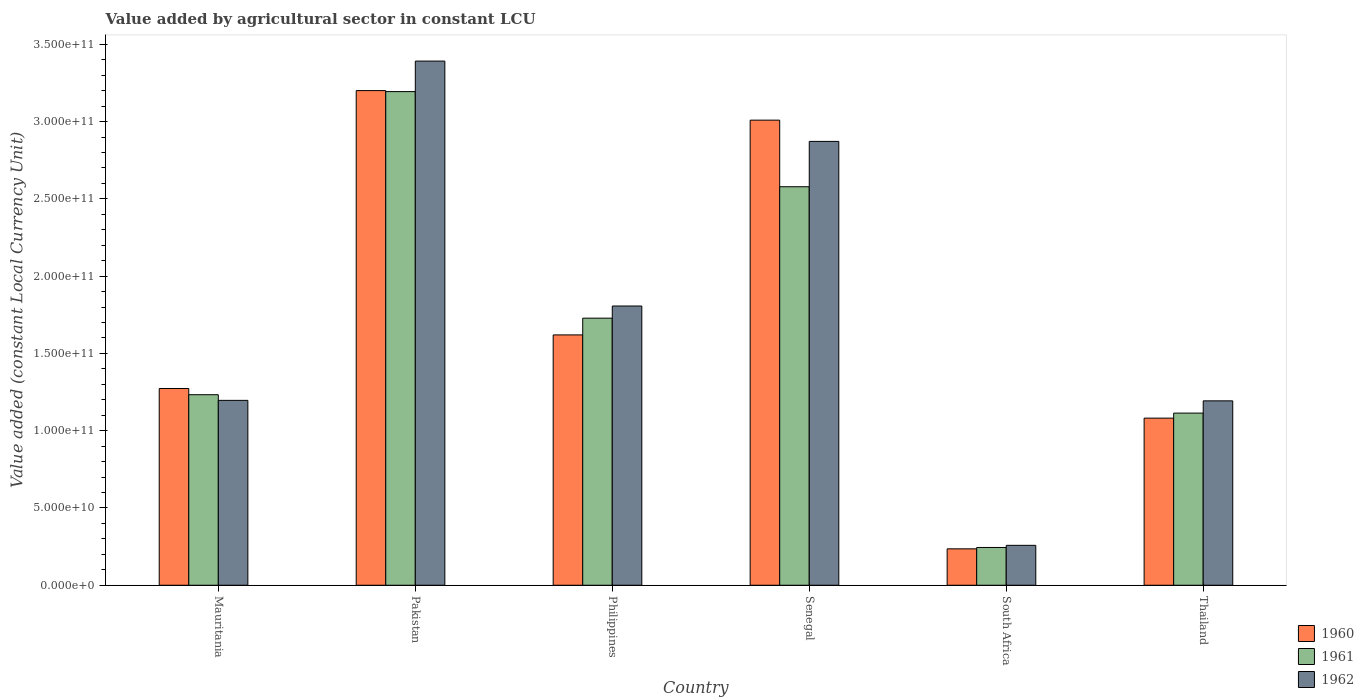Are the number of bars on each tick of the X-axis equal?
Provide a short and direct response. Yes. How many bars are there on the 6th tick from the left?
Offer a terse response. 3. What is the label of the 5th group of bars from the left?
Your answer should be very brief. South Africa. In how many cases, is the number of bars for a given country not equal to the number of legend labels?
Provide a succinct answer. 0. What is the value added by agricultural sector in 1960 in South Africa?
Your answer should be compact. 2.36e+1. Across all countries, what is the maximum value added by agricultural sector in 1960?
Offer a very short reply. 3.20e+11. Across all countries, what is the minimum value added by agricultural sector in 1960?
Ensure brevity in your answer.  2.36e+1. In which country was the value added by agricultural sector in 1962 maximum?
Provide a succinct answer. Pakistan. In which country was the value added by agricultural sector in 1960 minimum?
Your response must be concise. South Africa. What is the total value added by agricultural sector in 1962 in the graph?
Provide a succinct answer. 1.07e+12. What is the difference between the value added by agricultural sector in 1962 in South Africa and that in Thailand?
Keep it short and to the point. -9.35e+1. What is the difference between the value added by agricultural sector in 1960 in South Africa and the value added by agricultural sector in 1961 in Thailand?
Provide a short and direct response. -8.78e+1. What is the average value added by agricultural sector in 1961 per country?
Make the answer very short. 1.68e+11. What is the difference between the value added by agricultural sector of/in 1960 and value added by agricultural sector of/in 1961 in Mauritania?
Your answer should be very brief. 4.01e+09. In how many countries, is the value added by agricultural sector in 1961 greater than 50000000000 LCU?
Provide a succinct answer. 5. What is the ratio of the value added by agricultural sector in 1961 in Philippines to that in Senegal?
Provide a succinct answer. 0.67. What is the difference between the highest and the second highest value added by agricultural sector in 1960?
Ensure brevity in your answer.  1.91e+1. What is the difference between the highest and the lowest value added by agricultural sector in 1961?
Offer a terse response. 2.95e+11. Is it the case that in every country, the sum of the value added by agricultural sector in 1961 and value added by agricultural sector in 1962 is greater than the value added by agricultural sector in 1960?
Keep it short and to the point. Yes. How many bars are there?
Provide a short and direct response. 18. How many countries are there in the graph?
Ensure brevity in your answer.  6. Does the graph contain any zero values?
Your answer should be very brief. No. Does the graph contain grids?
Provide a succinct answer. No. How many legend labels are there?
Give a very brief answer. 3. What is the title of the graph?
Offer a very short reply. Value added by agricultural sector in constant LCU. What is the label or title of the X-axis?
Offer a terse response. Country. What is the label or title of the Y-axis?
Your response must be concise. Value added (constant Local Currency Unit). What is the Value added (constant Local Currency Unit) of 1960 in Mauritania?
Ensure brevity in your answer.  1.27e+11. What is the Value added (constant Local Currency Unit) in 1961 in Mauritania?
Make the answer very short. 1.23e+11. What is the Value added (constant Local Currency Unit) in 1962 in Mauritania?
Your answer should be very brief. 1.20e+11. What is the Value added (constant Local Currency Unit) of 1960 in Pakistan?
Give a very brief answer. 3.20e+11. What is the Value added (constant Local Currency Unit) in 1961 in Pakistan?
Your answer should be very brief. 3.19e+11. What is the Value added (constant Local Currency Unit) in 1962 in Pakistan?
Offer a very short reply. 3.39e+11. What is the Value added (constant Local Currency Unit) of 1960 in Philippines?
Your answer should be very brief. 1.62e+11. What is the Value added (constant Local Currency Unit) of 1961 in Philippines?
Your answer should be very brief. 1.73e+11. What is the Value added (constant Local Currency Unit) of 1962 in Philippines?
Ensure brevity in your answer.  1.81e+11. What is the Value added (constant Local Currency Unit) of 1960 in Senegal?
Your answer should be very brief. 3.01e+11. What is the Value added (constant Local Currency Unit) in 1961 in Senegal?
Provide a succinct answer. 2.58e+11. What is the Value added (constant Local Currency Unit) in 1962 in Senegal?
Offer a very short reply. 2.87e+11. What is the Value added (constant Local Currency Unit) in 1960 in South Africa?
Keep it short and to the point. 2.36e+1. What is the Value added (constant Local Currency Unit) of 1961 in South Africa?
Your answer should be very brief. 2.44e+1. What is the Value added (constant Local Currency Unit) of 1962 in South Africa?
Your answer should be compact. 2.58e+1. What is the Value added (constant Local Currency Unit) of 1960 in Thailand?
Offer a very short reply. 1.08e+11. What is the Value added (constant Local Currency Unit) of 1961 in Thailand?
Your response must be concise. 1.11e+11. What is the Value added (constant Local Currency Unit) in 1962 in Thailand?
Your response must be concise. 1.19e+11. Across all countries, what is the maximum Value added (constant Local Currency Unit) in 1960?
Give a very brief answer. 3.20e+11. Across all countries, what is the maximum Value added (constant Local Currency Unit) in 1961?
Your answer should be very brief. 3.19e+11. Across all countries, what is the maximum Value added (constant Local Currency Unit) in 1962?
Provide a succinct answer. 3.39e+11. Across all countries, what is the minimum Value added (constant Local Currency Unit) of 1960?
Your response must be concise. 2.36e+1. Across all countries, what is the minimum Value added (constant Local Currency Unit) in 1961?
Provide a short and direct response. 2.44e+1. Across all countries, what is the minimum Value added (constant Local Currency Unit) of 1962?
Keep it short and to the point. 2.58e+1. What is the total Value added (constant Local Currency Unit) of 1960 in the graph?
Your answer should be compact. 1.04e+12. What is the total Value added (constant Local Currency Unit) of 1961 in the graph?
Keep it short and to the point. 1.01e+12. What is the total Value added (constant Local Currency Unit) of 1962 in the graph?
Offer a very short reply. 1.07e+12. What is the difference between the Value added (constant Local Currency Unit) in 1960 in Mauritania and that in Pakistan?
Provide a short and direct response. -1.93e+11. What is the difference between the Value added (constant Local Currency Unit) in 1961 in Mauritania and that in Pakistan?
Provide a succinct answer. -1.96e+11. What is the difference between the Value added (constant Local Currency Unit) of 1962 in Mauritania and that in Pakistan?
Your answer should be very brief. -2.20e+11. What is the difference between the Value added (constant Local Currency Unit) in 1960 in Mauritania and that in Philippines?
Make the answer very short. -3.47e+1. What is the difference between the Value added (constant Local Currency Unit) of 1961 in Mauritania and that in Philippines?
Offer a very short reply. -4.95e+1. What is the difference between the Value added (constant Local Currency Unit) in 1962 in Mauritania and that in Philippines?
Ensure brevity in your answer.  -6.11e+1. What is the difference between the Value added (constant Local Currency Unit) in 1960 in Mauritania and that in Senegal?
Make the answer very short. -1.74e+11. What is the difference between the Value added (constant Local Currency Unit) of 1961 in Mauritania and that in Senegal?
Your answer should be very brief. -1.35e+11. What is the difference between the Value added (constant Local Currency Unit) of 1962 in Mauritania and that in Senegal?
Provide a succinct answer. -1.68e+11. What is the difference between the Value added (constant Local Currency Unit) in 1960 in Mauritania and that in South Africa?
Provide a short and direct response. 1.04e+11. What is the difference between the Value added (constant Local Currency Unit) of 1961 in Mauritania and that in South Africa?
Make the answer very short. 9.88e+1. What is the difference between the Value added (constant Local Currency Unit) in 1962 in Mauritania and that in South Africa?
Your answer should be very brief. 9.38e+1. What is the difference between the Value added (constant Local Currency Unit) of 1960 in Mauritania and that in Thailand?
Offer a terse response. 1.92e+1. What is the difference between the Value added (constant Local Currency Unit) of 1961 in Mauritania and that in Thailand?
Ensure brevity in your answer.  1.19e+1. What is the difference between the Value added (constant Local Currency Unit) of 1962 in Mauritania and that in Thailand?
Offer a terse response. 3.11e+08. What is the difference between the Value added (constant Local Currency Unit) in 1960 in Pakistan and that in Philippines?
Your answer should be very brief. 1.58e+11. What is the difference between the Value added (constant Local Currency Unit) of 1961 in Pakistan and that in Philippines?
Make the answer very short. 1.47e+11. What is the difference between the Value added (constant Local Currency Unit) in 1962 in Pakistan and that in Philippines?
Provide a succinct answer. 1.58e+11. What is the difference between the Value added (constant Local Currency Unit) of 1960 in Pakistan and that in Senegal?
Offer a very short reply. 1.91e+1. What is the difference between the Value added (constant Local Currency Unit) of 1961 in Pakistan and that in Senegal?
Offer a terse response. 6.16e+1. What is the difference between the Value added (constant Local Currency Unit) in 1962 in Pakistan and that in Senegal?
Provide a succinct answer. 5.20e+1. What is the difference between the Value added (constant Local Currency Unit) of 1960 in Pakistan and that in South Africa?
Give a very brief answer. 2.97e+11. What is the difference between the Value added (constant Local Currency Unit) of 1961 in Pakistan and that in South Africa?
Your response must be concise. 2.95e+11. What is the difference between the Value added (constant Local Currency Unit) of 1962 in Pakistan and that in South Africa?
Offer a terse response. 3.13e+11. What is the difference between the Value added (constant Local Currency Unit) of 1960 in Pakistan and that in Thailand?
Your answer should be very brief. 2.12e+11. What is the difference between the Value added (constant Local Currency Unit) in 1961 in Pakistan and that in Thailand?
Offer a very short reply. 2.08e+11. What is the difference between the Value added (constant Local Currency Unit) in 1962 in Pakistan and that in Thailand?
Your answer should be compact. 2.20e+11. What is the difference between the Value added (constant Local Currency Unit) in 1960 in Philippines and that in Senegal?
Provide a succinct answer. -1.39e+11. What is the difference between the Value added (constant Local Currency Unit) in 1961 in Philippines and that in Senegal?
Keep it short and to the point. -8.50e+1. What is the difference between the Value added (constant Local Currency Unit) in 1962 in Philippines and that in Senegal?
Offer a very short reply. -1.07e+11. What is the difference between the Value added (constant Local Currency Unit) in 1960 in Philippines and that in South Africa?
Your answer should be very brief. 1.38e+11. What is the difference between the Value added (constant Local Currency Unit) of 1961 in Philippines and that in South Africa?
Keep it short and to the point. 1.48e+11. What is the difference between the Value added (constant Local Currency Unit) in 1962 in Philippines and that in South Africa?
Provide a short and direct response. 1.55e+11. What is the difference between the Value added (constant Local Currency Unit) of 1960 in Philippines and that in Thailand?
Your response must be concise. 5.39e+1. What is the difference between the Value added (constant Local Currency Unit) of 1961 in Philippines and that in Thailand?
Make the answer very short. 6.14e+1. What is the difference between the Value added (constant Local Currency Unit) in 1962 in Philippines and that in Thailand?
Make the answer very short. 6.14e+1. What is the difference between the Value added (constant Local Currency Unit) in 1960 in Senegal and that in South Africa?
Ensure brevity in your answer.  2.77e+11. What is the difference between the Value added (constant Local Currency Unit) in 1961 in Senegal and that in South Africa?
Offer a very short reply. 2.33e+11. What is the difference between the Value added (constant Local Currency Unit) in 1962 in Senegal and that in South Africa?
Give a very brief answer. 2.61e+11. What is the difference between the Value added (constant Local Currency Unit) of 1960 in Senegal and that in Thailand?
Your answer should be very brief. 1.93e+11. What is the difference between the Value added (constant Local Currency Unit) of 1961 in Senegal and that in Thailand?
Provide a succinct answer. 1.46e+11. What is the difference between the Value added (constant Local Currency Unit) in 1962 in Senegal and that in Thailand?
Offer a terse response. 1.68e+11. What is the difference between the Value added (constant Local Currency Unit) in 1960 in South Africa and that in Thailand?
Offer a terse response. -8.46e+1. What is the difference between the Value added (constant Local Currency Unit) in 1961 in South Africa and that in Thailand?
Your response must be concise. -8.70e+1. What is the difference between the Value added (constant Local Currency Unit) of 1962 in South Africa and that in Thailand?
Give a very brief answer. -9.35e+1. What is the difference between the Value added (constant Local Currency Unit) in 1960 in Mauritania and the Value added (constant Local Currency Unit) in 1961 in Pakistan?
Offer a terse response. -1.92e+11. What is the difference between the Value added (constant Local Currency Unit) of 1960 in Mauritania and the Value added (constant Local Currency Unit) of 1962 in Pakistan?
Provide a short and direct response. -2.12e+11. What is the difference between the Value added (constant Local Currency Unit) in 1961 in Mauritania and the Value added (constant Local Currency Unit) in 1962 in Pakistan?
Offer a terse response. -2.16e+11. What is the difference between the Value added (constant Local Currency Unit) of 1960 in Mauritania and the Value added (constant Local Currency Unit) of 1961 in Philippines?
Make the answer very short. -4.55e+1. What is the difference between the Value added (constant Local Currency Unit) of 1960 in Mauritania and the Value added (constant Local Currency Unit) of 1962 in Philippines?
Make the answer very short. -5.34e+1. What is the difference between the Value added (constant Local Currency Unit) of 1961 in Mauritania and the Value added (constant Local Currency Unit) of 1962 in Philippines?
Offer a terse response. -5.74e+1. What is the difference between the Value added (constant Local Currency Unit) in 1960 in Mauritania and the Value added (constant Local Currency Unit) in 1961 in Senegal?
Provide a succinct answer. -1.31e+11. What is the difference between the Value added (constant Local Currency Unit) in 1960 in Mauritania and the Value added (constant Local Currency Unit) in 1962 in Senegal?
Provide a succinct answer. -1.60e+11. What is the difference between the Value added (constant Local Currency Unit) of 1961 in Mauritania and the Value added (constant Local Currency Unit) of 1962 in Senegal?
Offer a terse response. -1.64e+11. What is the difference between the Value added (constant Local Currency Unit) in 1960 in Mauritania and the Value added (constant Local Currency Unit) in 1961 in South Africa?
Provide a succinct answer. 1.03e+11. What is the difference between the Value added (constant Local Currency Unit) of 1960 in Mauritania and the Value added (constant Local Currency Unit) of 1962 in South Africa?
Ensure brevity in your answer.  1.01e+11. What is the difference between the Value added (constant Local Currency Unit) in 1961 in Mauritania and the Value added (constant Local Currency Unit) in 1962 in South Africa?
Your answer should be compact. 9.75e+1. What is the difference between the Value added (constant Local Currency Unit) of 1960 in Mauritania and the Value added (constant Local Currency Unit) of 1961 in Thailand?
Offer a terse response. 1.59e+1. What is the difference between the Value added (constant Local Currency Unit) in 1960 in Mauritania and the Value added (constant Local Currency Unit) in 1962 in Thailand?
Ensure brevity in your answer.  7.98e+09. What is the difference between the Value added (constant Local Currency Unit) of 1961 in Mauritania and the Value added (constant Local Currency Unit) of 1962 in Thailand?
Offer a terse response. 3.97e+09. What is the difference between the Value added (constant Local Currency Unit) in 1960 in Pakistan and the Value added (constant Local Currency Unit) in 1961 in Philippines?
Provide a succinct answer. 1.47e+11. What is the difference between the Value added (constant Local Currency Unit) in 1960 in Pakistan and the Value added (constant Local Currency Unit) in 1962 in Philippines?
Make the answer very short. 1.39e+11. What is the difference between the Value added (constant Local Currency Unit) of 1961 in Pakistan and the Value added (constant Local Currency Unit) of 1962 in Philippines?
Make the answer very short. 1.39e+11. What is the difference between the Value added (constant Local Currency Unit) in 1960 in Pakistan and the Value added (constant Local Currency Unit) in 1961 in Senegal?
Your answer should be compact. 6.22e+1. What is the difference between the Value added (constant Local Currency Unit) in 1960 in Pakistan and the Value added (constant Local Currency Unit) in 1962 in Senegal?
Your answer should be very brief. 3.29e+1. What is the difference between the Value added (constant Local Currency Unit) of 1961 in Pakistan and the Value added (constant Local Currency Unit) of 1962 in Senegal?
Give a very brief answer. 3.22e+1. What is the difference between the Value added (constant Local Currency Unit) in 1960 in Pakistan and the Value added (constant Local Currency Unit) in 1961 in South Africa?
Provide a short and direct response. 2.96e+11. What is the difference between the Value added (constant Local Currency Unit) of 1960 in Pakistan and the Value added (constant Local Currency Unit) of 1962 in South Africa?
Ensure brevity in your answer.  2.94e+11. What is the difference between the Value added (constant Local Currency Unit) of 1961 in Pakistan and the Value added (constant Local Currency Unit) of 1962 in South Africa?
Keep it short and to the point. 2.94e+11. What is the difference between the Value added (constant Local Currency Unit) of 1960 in Pakistan and the Value added (constant Local Currency Unit) of 1961 in Thailand?
Your answer should be very brief. 2.09e+11. What is the difference between the Value added (constant Local Currency Unit) of 1960 in Pakistan and the Value added (constant Local Currency Unit) of 1962 in Thailand?
Your response must be concise. 2.01e+11. What is the difference between the Value added (constant Local Currency Unit) of 1961 in Pakistan and the Value added (constant Local Currency Unit) of 1962 in Thailand?
Provide a succinct answer. 2.00e+11. What is the difference between the Value added (constant Local Currency Unit) of 1960 in Philippines and the Value added (constant Local Currency Unit) of 1961 in Senegal?
Give a very brief answer. -9.59e+1. What is the difference between the Value added (constant Local Currency Unit) in 1960 in Philippines and the Value added (constant Local Currency Unit) in 1962 in Senegal?
Provide a short and direct response. -1.25e+11. What is the difference between the Value added (constant Local Currency Unit) in 1961 in Philippines and the Value added (constant Local Currency Unit) in 1962 in Senegal?
Your answer should be very brief. -1.14e+11. What is the difference between the Value added (constant Local Currency Unit) in 1960 in Philippines and the Value added (constant Local Currency Unit) in 1961 in South Africa?
Provide a short and direct response. 1.38e+11. What is the difference between the Value added (constant Local Currency Unit) of 1960 in Philippines and the Value added (constant Local Currency Unit) of 1962 in South Africa?
Give a very brief answer. 1.36e+11. What is the difference between the Value added (constant Local Currency Unit) in 1961 in Philippines and the Value added (constant Local Currency Unit) in 1962 in South Africa?
Offer a very short reply. 1.47e+11. What is the difference between the Value added (constant Local Currency Unit) in 1960 in Philippines and the Value added (constant Local Currency Unit) in 1961 in Thailand?
Offer a terse response. 5.06e+1. What is the difference between the Value added (constant Local Currency Unit) in 1960 in Philippines and the Value added (constant Local Currency Unit) in 1962 in Thailand?
Give a very brief answer. 4.27e+1. What is the difference between the Value added (constant Local Currency Unit) of 1961 in Philippines and the Value added (constant Local Currency Unit) of 1962 in Thailand?
Offer a very short reply. 5.35e+1. What is the difference between the Value added (constant Local Currency Unit) in 1960 in Senegal and the Value added (constant Local Currency Unit) in 1961 in South Africa?
Your answer should be very brief. 2.77e+11. What is the difference between the Value added (constant Local Currency Unit) in 1960 in Senegal and the Value added (constant Local Currency Unit) in 1962 in South Africa?
Ensure brevity in your answer.  2.75e+11. What is the difference between the Value added (constant Local Currency Unit) of 1961 in Senegal and the Value added (constant Local Currency Unit) of 1962 in South Africa?
Offer a very short reply. 2.32e+11. What is the difference between the Value added (constant Local Currency Unit) of 1960 in Senegal and the Value added (constant Local Currency Unit) of 1961 in Thailand?
Offer a very short reply. 1.90e+11. What is the difference between the Value added (constant Local Currency Unit) in 1960 in Senegal and the Value added (constant Local Currency Unit) in 1962 in Thailand?
Your answer should be compact. 1.82e+11. What is the difference between the Value added (constant Local Currency Unit) in 1961 in Senegal and the Value added (constant Local Currency Unit) in 1962 in Thailand?
Your answer should be compact. 1.39e+11. What is the difference between the Value added (constant Local Currency Unit) of 1960 in South Africa and the Value added (constant Local Currency Unit) of 1961 in Thailand?
Offer a very short reply. -8.78e+1. What is the difference between the Value added (constant Local Currency Unit) of 1960 in South Africa and the Value added (constant Local Currency Unit) of 1962 in Thailand?
Offer a very short reply. -9.58e+1. What is the difference between the Value added (constant Local Currency Unit) of 1961 in South Africa and the Value added (constant Local Currency Unit) of 1962 in Thailand?
Make the answer very short. -9.49e+1. What is the average Value added (constant Local Currency Unit) in 1960 per country?
Make the answer very short. 1.74e+11. What is the average Value added (constant Local Currency Unit) of 1961 per country?
Give a very brief answer. 1.68e+11. What is the average Value added (constant Local Currency Unit) in 1962 per country?
Make the answer very short. 1.79e+11. What is the difference between the Value added (constant Local Currency Unit) of 1960 and Value added (constant Local Currency Unit) of 1961 in Mauritania?
Your answer should be compact. 4.01e+09. What is the difference between the Value added (constant Local Currency Unit) of 1960 and Value added (constant Local Currency Unit) of 1962 in Mauritania?
Give a very brief answer. 7.67e+09. What is the difference between the Value added (constant Local Currency Unit) of 1961 and Value added (constant Local Currency Unit) of 1962 in Mauritania?
Provide a succinct answer. 3.65e+09. What is the difference between the Value added (constant Local Currency Unit) in 1960 and Value added (constant Local Currency Unit) in 1961 in Pakistan?
Offer a terse response. 6.46e+08. What is the difference between the Value added (constant Local Currency Unit) in 1960 and Value added (constant Local Currency Unit) in 1962 in Pakistan?
Provide a short and direct response. -1.91e+1. What is the difference between the Value added (constant Local Currency Unit) of 1961 and Value added (constant Local Currency Unit) of 1962 in Pakistan?
Your response must be concise. -1.97e+1. What is the difference between the Value added (constant Local Currency Unit) in 1960 and Value added (constant Local Currency Unit) in 1961 in Philippines?
Ensure brevity in your answer.  -1.08e+1. What is the difference between the Value added (constant Local Currency Unit) in 1960 and Value added (constant Local Currency Unit) in 1962 in Philippines?
Ensure brevity in your answer.  -1.87e+1. What is the difference between the Value added (constant Local Currency Unit) of 1961 and Value added (constant Local Currency Unit) of 1962 in Philippines?
Ensure brevity in your answer.  -7.86e+09. What is the difference between the Value added (constant Local Currency Unit) of 1960 and Value added (constant Local Currency Unit) of 1961 in Senegal?
Your answer should be very brief. 4.31e+1. What is the difference between the Value added (constant Local Currency Unit) of 1960 and Value added (constant Local Currency Unit) of 1962 in Senegal?
Make the answer very short. 1.38e+1. What is the difference between the Value added (constant Local Currency Unit) of 1961 and Value added (constant Local Currency Unit) of 1962 in Senegal?
Your response must be concise. -2.93e+1. What is the difference between the Value added (constant Local Currency Unit) of 1960 and Value added (constant Local Currency Unit) of 1961 in South Africa?
Give a very brief answer. -8.75e+08. What is the difference between the Value added (constant Local Currency Unit) in 1960 and Value added (constant Local Currency Unit) in 1962 in South Africa?
Keep it short and to the point. -2.26e+09. What is the difference between the Value added (constant Local Currency Unit) of 1961 and Value added (constant Local Currency Unit) of 1962 in South Africa?
Provide a succinct answer. -1.39e+09. What is the difference between the Value added (constant Local Currency Unit) in 1960 and Value added (constant Local Currency Unit) in 1961 in Thailand?
Your answer should be very brief. -3.26e+09. What is the difference between the Value added (constant Local Currency Unit) of 1960 and Value added (constant Local Currency Unit) of 1962 in Thailand?
Give a very brief answer. -1.12e+1. What is the difference between the Value added (constant Local Currency Unit) of 1961 and Value added (constant Local Currency Unit) of 1962 in Thailand?
Give a very brief answer. -7.93e+09. What is the ratio of the Value added (constant Local Currency Unit) of 1960 in Mauritania to that in Pakistan?
Make the answer very short. 0.4. What is the ratio of the Value added (constant Local Currency Unit) in 1961 in Mauritania to that in Pakistan?
Provide a short and direct response. 0.39. What is the ratio of the Value added (constant Local Currency Unit) in 1962 in Mauritania to that in Pakistan?
Give a very brief answer. 0.35. What is the ratio of the Value added (constant Local Currency Unit) of 1960 in Mauritania to that in Philippines?
Ensure brevity in your answer.  0.79. What is the ratio of the Value added (constant Local Currency Unit) in 1961 in Mauritania to that in Philippines?
Offer a terse response. 0.71. What is the ratio of the Value added (constant Local Currency Unit) of 1962 in Mauritania to that in Philippines?
Keep it short and to the point. 0.66. What is the ratio of the Value added (constant Local Currency Unit) in 1960 in Mauritania to that in Senegal?
Keep it short and to the point. 0.42. What is the ratio of the Value added (constant Local Currency Unit) of 1961 in Mauritania to that in Senegal?
Your answer should be compact. 0.48. What is the ratio of the Value added (constant Local Currency Unit) in 1962 in Mauritania to that in Senegal?
Ensure brevity in your answer.  0.42. What is the ratio of the Value added (constant Local Currency Unit) in 1960 in Mauritania to that in South Africa?
Ensure brevity in your answer.  5.4. What is the ratio of the Value added (constant Local Currency Unit) in 1961 in Mauritania to that in South Africa?
Provide a succinct answer. 5.05. What is the ratio of the Value added (constant Local Currency Unit) of 1962 in Mauritania to that in South Africa?
Your response must be concise. 4.63. What is the ratio of the Value added (constant Local Currency Unit) in 1960 in Mauritania to that in Thailand?
Your response must be concise. 1.18. What is the ratio of the Value added (constant Local Currency Unit) of 1961 in Mauritania to that in Thailand?
Your response must be concise. 1.11. What is the ratio of the Value added (constant Local Currency Unit) in 1962 in Mauritania to that in Thailand?
Ensure brevity in your answer.  1. What is the ratio of the Value added (constant Local Currency Unit) of 1960 in Pakistan to that in Philippines?
Your answer should be compact. 1.98. What is the ratio of the Value added (constant Local Currency Unit) of 1961 in Pakistan to that in Philippines?
Your answer should be very brief. 1.85. What is the ratio of the Value added (constant Local Currency Unit) of 1962 in Pakistan to that in Philippines?
Your answer should be compact. 1.88. What is the ratio of the Value added (constant Local Currency Unit) of 1960 in Pakistan to that in Senegal?
Your answer should be very brief. 1.06. What is the ratio of the Value added (constant Local Currency Unit) of 1961 in Pakistan to that in Senegal?
Keep it short and to the point. 1.24. What is the ratio of the Value added (constant Local Currency Unit) in 1962 in Pakistan to that in Senegal?
Give a very brief answer. 1.18. What is the ratio of the Value added (constant Local Currency Unit) in 1960 in Pakistan to that in South Africa?
Offer a very short reply. 13.59. What is the ratio of the Value added (constant Local Currency Unit) in 1961 in Pakistan to that in South Africa?
Your response must be concise. 13.07. What is the ratio of the Value added (constant Local Currency Unit) in 1962 in Pakistan to that in South Africa?
Ensure brevity in your answer.  13.14. What is the ratio of the Value added (constant Local Currency Unit) of 1960 in Pakistan to that in Thailand?
Your answer should be very brief. 2.96. What is the ratio of the Value added (constant Local Currency Unit) in 1961 in Pakistan to that in Thailand?
Provide a succinct answer. 2.87. What is the ratio of the Value added (constant Local Currency Unit) of 1962 in Pakistan to that in Thailand?
Your response must be concise. 2.84. What is the ratio of the Value added (constant Local Currency Unit) in 1960 in Philippines to that in Senegal?
Your response must be concise. 0.54. What is the ratio of the Value added (constant Local Currency Unit) of 1961 in Philippines to that in Senegal?
Your answer should be very brief. 0.67. What is the ratio of the Value added (constant Local Currency Unit) of 1962 in Philippines to that in Senegal?
Ensure brevity in your answer.  0.63. What is the ratio of the Value added (constant Local Currency Unit) of 1960 in Philippines to that in South Africa?
Give a very brief answer. 6.88. What is the ratio of the Value added (constant Local Currency Unit) in 1961 in Philippines to that in South Africa?
Give a very brief answer. 7.07. What is the ratio of the Value added (constant Local Currency Unit) of 1962 in Philippines to that in South Africa?
Keep it short and to the point. 7. What is the ratio of the Value added (constant Local Currency Unit) of 1960 in Philippines to that in Thailand?
Offer a very short reply. 1.5. What is the ratio of the Value added (constant Local Currency Unit) in 1961 in Philippines to that in Thailand?
Provide a short and direct response. 1.55. What is the ratio of the Value added (constant Local Currency Unit) of 1962 in Philippines to that in Thailand?
Keep it short and to the point. 1.51. What is the ratio of the Value added (constant Local Currency Unit) of 1960 in Senegal to that in South Africa?
Offer a very short reply. 12.77. What is the ratio of the Value added (constant Local Currency Unit) in 1961 in Senegal to that in South Africa?
Ensure brevity in your answer.  10.55. What is the ratio of the Value added (constant Local Currency Unit) in 1962 in Senegal to that in South Africa?
Ensure brevity in your answer.  11.12. What is the ratio of the Value added (constant Local Currency Unit) in 1960 in Senegal to that in Thailand?
Provide a succinct answer. 2.78. What is the ratio of the Value added (constant Local Currency Unit) in 1961 in Senegal to that in Thailand?
Your answer should be very brief. 2.31. What is the ratio of the Value added (constant Local Currency Unit) in 1962 in Senegal to that in Thailand?
Your answer should be compact. 2.41. What is the ratio of the Value added (constant Local Currency Unit) of 1960 in South Africa to that in Thailand?
Your answer should be compact. 0.22. What is the ratio of the Value added (constant Local Currency Unit) in 1961 in South Africa to that in Thailand?
Keep it short and to the point. 0.22. What is the ratio of the Value added (constant Local Currency Unit) in 1962 in South Africa to that in Thailand?
Your response must be concise. 0.22. What is the difference between the highest and the second highest Value added (constant Local Currency Unit) of 1960?
Keep it short and to the point. 1.91e+1. What is the difference between the highest and the second highest Value added (constant Local Currency Unit) in 1961?
Ensure brevity in your answer.  6.16e+1. What is the difference between the highest and the second highest Value added (constant Local Currency Unit) in 1962?
Offer a very short reply. 5.20e+1. What is the difference between the highest and the lowest Value added (constant Local Currency Unit) in 1960?
Keep it short and to the point. 2.97e+11. What is the difference between the highest and the lowest Value added (constant Local Currency Unit) of 1961?
Provide a succinct answer. 2.95e+11. What is the difference between the highest and the lowest Value added (constant Local Currency Unit) in 1962?
Offer a terse response. 3.13e+11. 